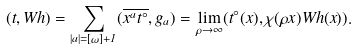Convert formula to latex. <formula><loc_0><loc_0><loc_500><loc_500>( t , W h ) = \sum _ { | a | = [ \omega ] + 1 } ( \overline { x ^ { a } t ^ { \circ } } , g _ { a } ) = \lim _ { \rho \to \infty } ( t ^ { \circ } ( x ) , \chi ( \rho x ) W h ( x ) ) .</formula> 